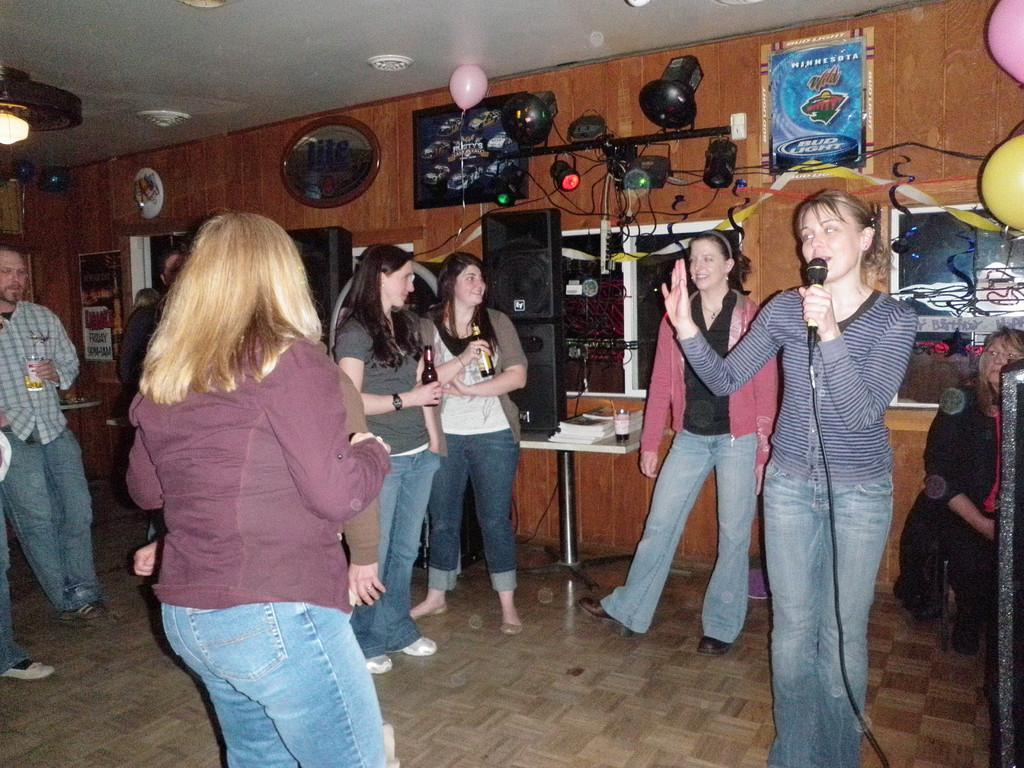Can you describe this image briefly? In this picture we can see some people, two women are holding bottles with their hands and a woman holding a mic with her hand. In the background we can see speakers, lights, tables, books, windows, posters, balloons, cables, ceiling and some objects. 